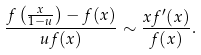<formula> <loc_0><loc_0><loc_500><loc_500>\frac { f \left ( \frac { x } { 1 - u } \right ) - f ( x ) } { u f ( x ) } \sim \frac { x f ^ { \prime } ( x ) } { f ( x ) } .</formula> 